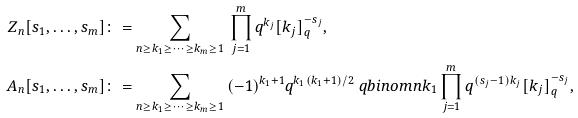Convert formula to latex. <formula><loc_0><loc_0><loc_500><loc_500>Z _ { n } [ s _ { 1 } , \dots , s _ { m } ] & \colon = \sum _ { n \geq k _ { 1 } \geq \cdots \geq k _ { m } \geq 1 } \, \prod _ { j = 1 } ^ { m } q ^ { k _ { j } } [ k _ { j } ] _ { q } ^ { - s _ { j } } , \\ A _ { n } [ s _ { 1 } , \dots , s _ { m } ] & \colon = \sum _ { n \geq k _ { 1 } \geq \cdots \geq k _ { m } \geq 1 } \, ( - 1 ) ^ { k _ { 1 } + 1 } q ^ { k _ { 1 } ( k _ { 1 } + 1 ) / 2 } \ q b i n o m { n } { k _ { 1 } } \prod _ { j = 1 } ^ { m } q ^ { ( s _ { j } - 1 ) k _ { j } } [ k _ { j } ] _ { q } ^ { - s _ { j } } ,</formula> 